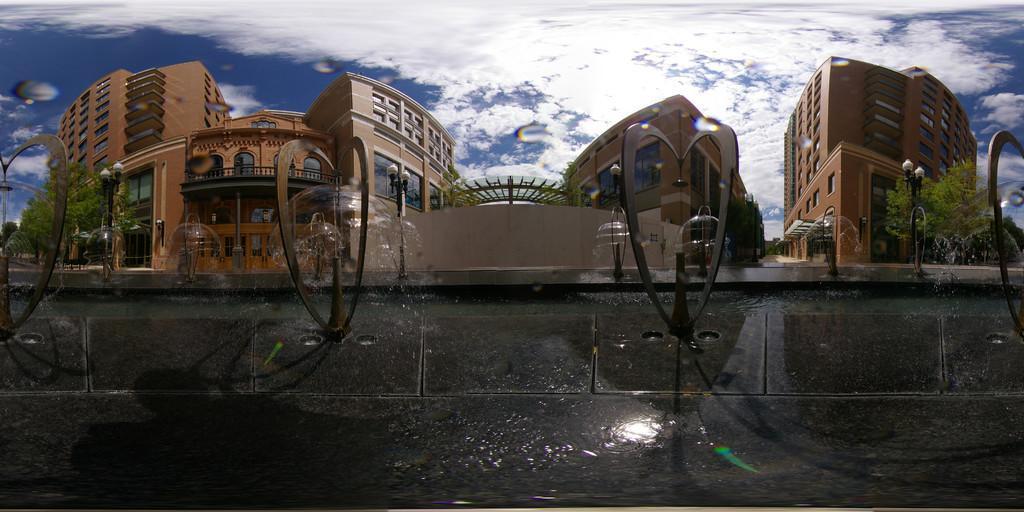Describe this image in one or two sentences. In this image in front there is a compound wall with metal structures. In the background of the image there are buildings, trees, lamp posts. At the top of the image there are clouds in the sky. 